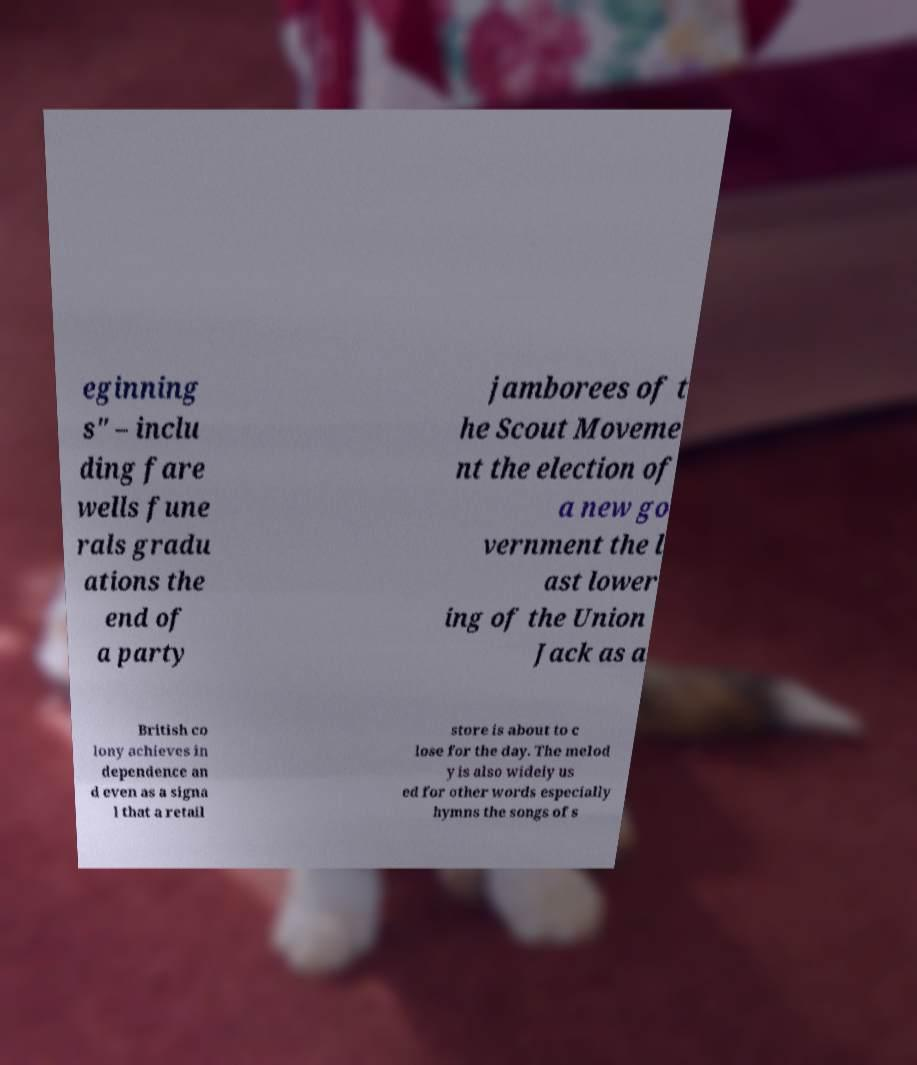What messages or text are displayed in this image? I need them in a readable, typed format. eginning s" – inclu ding fare wells fune rals gradu ations the end of a party jamborees of t he Scout Moveme nt the election of a new go vernment the l ast lower ing of the Union Jack as a British co lony achieves in dependence an d even as a signa l that a retail store is about to c lose for the day. The melod y is also widely us ed for other words especially hymns the songs of s 